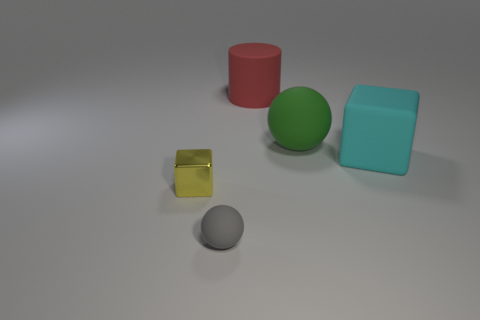Add 1 tiny brown matte objects. How many objects exist? 6 Subtract all cylinders. How many objects are left? 4 Add 1 small metallic objects. How many small metallic objects exist? 2 Subtract 1 cyan cubes. How many objects are left? 4 Subtract all tiny red spheres. Subtract all large cyan matte cubes. How many objects are left? 4 Add 5 rubber cylinders. How many rubber cylinders are left? 6 